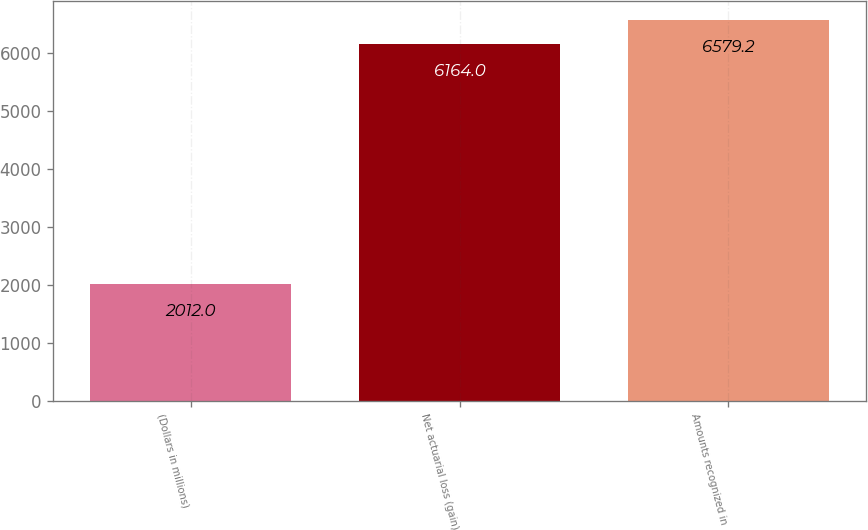Convert chart. <chart><loc_0><loc_0><loc_500><loc_500><bar_chart><fcel>(Dollars in millions)<fcel>Net actuarial loss (gain)<fcel>Amounts recognized in<nl><fcel>2012<fcel>6164<fcel>6579.2<nl></chart> 